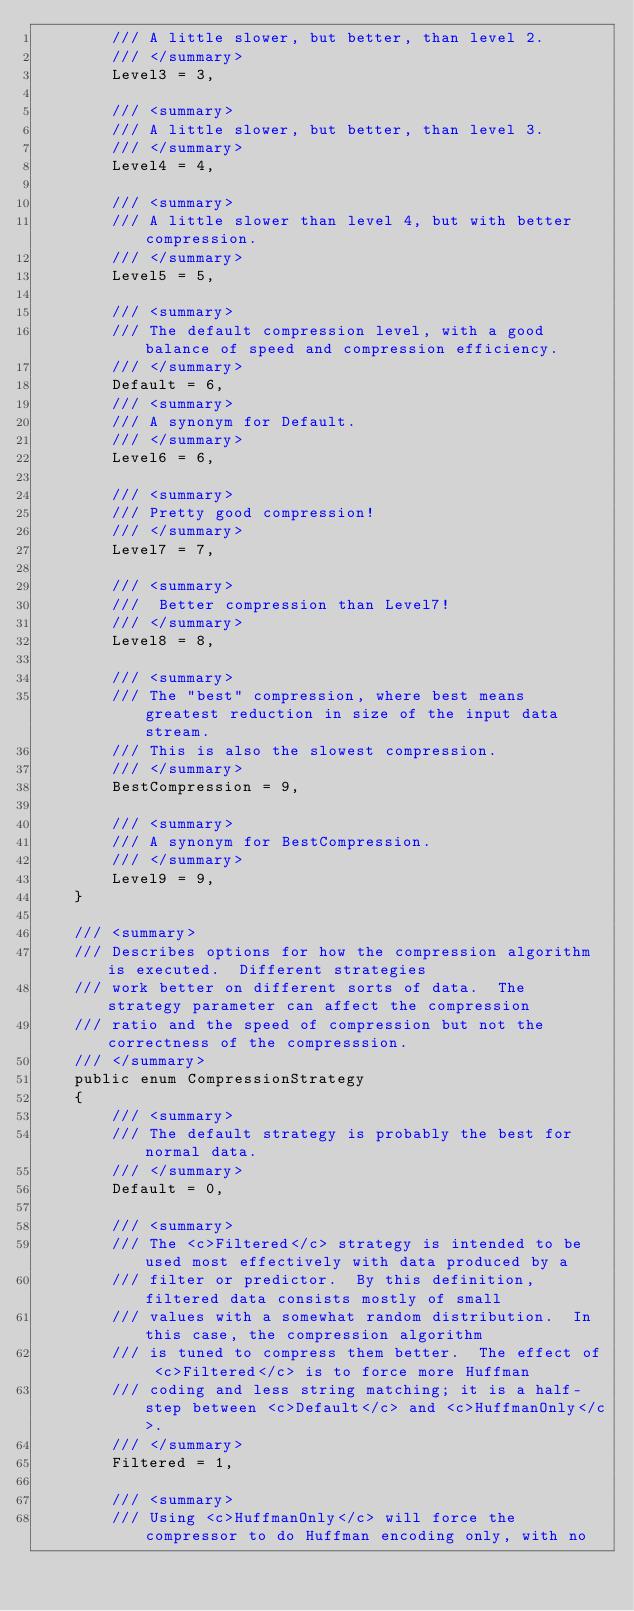Convert code to text. <code><loc_0><loc_0><loc_500><loc_500><_C#_>        /// A little slower, but better, than level 2.
        /// </summary>
        Level3 = 3,

        /// <summary>
        /// A little slower, but better, than level 3.
        /// </summary>
        Level4 = 4,

        /// <summary>
        /// A little slower than level 4, but with better compression.
        /// </summary>
        Level5 = 5,

        /// <summary>
        /// The default compression level, with a good balance of speed and compression efficiency.
        /// </summary>
        Default = 6,
        /// <summary>
        /// A synonym for Default.
        /// </summary>
        Level6 = 6,

        /// <summary>
        /// Pretty good compression!
        /// </summary>
        Level7 = 7,

        /// <summary>
        ///  Better compression than Level7!
        /// </summary>
        Level8 = 8,

        /// <summary>
        /// The "best" compression, where best means greatest reduction in size of the input data stream.
        /// This is also the slowest compression.
        /// </summary>
        BestCompression = 9,

        /// <summary>
        /// A synonym for BestCompression.
        /// </summary>
        Level9 = 9,
    }

    /// <summary>
    /// Describes options for how the compression algorithm is executed.  Different strategies
    /// work better on different sorts of data.  The strategy parameter can affect the compression
    /// ratio and the speed of compression but not the correctness of the compresssion.
    /// </summary>
    public enum CompressionStrategy
    {
        /// <summary>
        /// The default strategy is probably the best for normal data.
        /// </summary>
        Default = 0,

        /// <summary>
        /// The <c>Filtered</c> strategy is intended to be used most effectively with data produced by a
        /// filter or predictor.  By this definition, filtered data consists mostly of small
        /// values with a somewhat random distribution.  In this case, the compression algorithm
        /// is tuned to compress them better.  The effect of <c>Filtered</c> is to force more Huffman
        /// coding and less string matching; it is a half-step between <c>Default</c> and <c>HuffmanOnly</c>.
        /// </summary>
        Filtered = 1,

        /// <summary>
        /// Using <c>HuffmanOnly</c> will force the compressor to do Huffman encoding only, with no</code> 